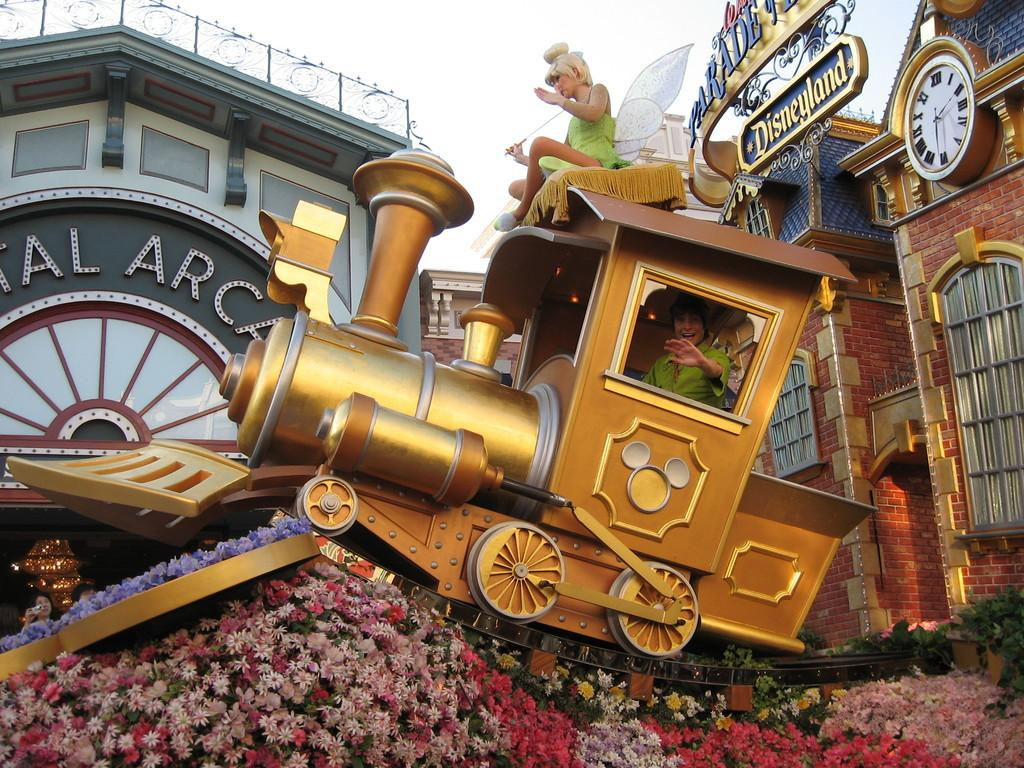<image>
Render a clear and concise summary of the photo. a Disneyland Peter Pan train with someone inside it. 